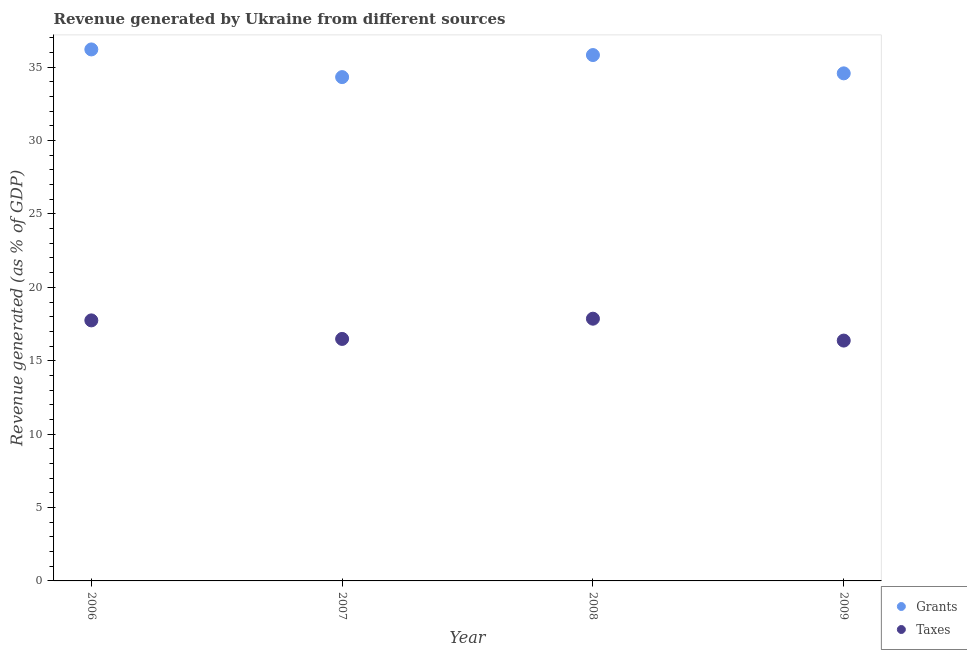What is the revenue generated by taxes in 2009?
Ensure brevity in your answer.  16.37. Across all years, what is the maximum revenue generated by taxes?
Offer a terse response. 17.86. Across all years, what is the minimum revenue generated by grants?
Your answer should be compact. 34.32. In which year was the revenue generated by taxes maximum?
Provide a short and direct response. 2008. What is the total revenue generated by taxes in the graph?
Offer a terse response. 68.47. What is the difference between the revenue generated by taxes in 2008 and that in 2009?
Your response must be concise. 1.49. What is the difference between the revenue generated by grants in 2007 and the revenue generated by taxes in 2008?
Keep it short and to the point. 16.46. What is the average revenue generated by taxes per year?
Keep it short and to the point. 17.12. In the year 2009, what is the difference between the revenue generated by grants and revenue generated by taxes?
Provide a succinct answer. 18.2. In how many years, is the revenue generated by taxes greater than 22 %?
Offer a very short reply. 0. What is the ratio of the revenue generated by grants in 2007 to that in 2008?
Provide a succinct answer. 0.96. Is the revenue generated by grants in 2007 less than that in 2009?
Your response must be concise. Yes. Is the difference between the revenue generated by grants in 2006 and 2007 greater than the difference between the revenue generated by taxes in 2006 and 2007?
Keep it short and to the point. Yes. What is the difference between the highest and the second highest revenue generated by taxes?
Your answer should be very brief. 0.12. What is the difference between the highest and the lowest revenue generated by grants?
Provide a succinct answer. 1.88. Is the revenue generated by taxes strictly greater than the revenue generated by grants over the years?
Provide a short and direct response. No. How many years are there in the graph?
Your response must be concise. 4. What is the difference between two consecutive major ticks on the Y-axis?
Give a very brief answer. 5. Are the values on the major ticks of Y-axis written in scientific E-notation?
Provide a short and direct response. No. Where does the legend appear in the graph?
Make the answer very short. Bottom right. What is the title of the graph?
Give a very brief answer. Revenue generated by Ukraine from different sources. Does "Methane" appear as one of the legend labels in the graph?
Your answer should be very brief. No. What is the label or title of the X-axis?
Offer a very short reply. Year. What is the label or title of the Y-axis?
Offer a very short reply. Revenue generated (as % of GDP). What is the Revenue generated (as % of GDP) in Grants in 2006?
Your answer should be compact. 36.2. What is the Revenue generated (as % of GDP) in Taxes in 2006?
Offer a very short reply. 17.75. What is the Revenue generated (as % of GDP) in Grants in 2007?
Offer a terse response. 34.32. What is the Revenue generated (as % of GDP) of Taxes in 2007?
Keep it short and to the point. 16.48. What is the Revenue generated (as % of GDP) in Grants in 2008?
Ensure brevity in your answer.  35.82. What is the Revenue generated (as % of GDP) of Taxes in 2008?
Your answer should be very brief. 17.86. What is the Revenue generated (as % of GDP) of Grants in 2009?
Offer a very short reply. 34.58. What is the Revenue generated (as % of GDP) of Taxes in 2009?
Provide a short and direct response. 16.37. Across all years, what is the maximum Revenue generated (as % of GDP) of Grants?
Your response must be concise. 36.2. Across all years, what is the maximum Revenue generated (as % of GDP) in Taxes?
Your answer should be compact. 17.86. Across all years, what is the minimum Revenue generated (as % of GDP) in Grants?
Your answer should be compact. 34.32. Across all years, what is the minimum Revenue generated (as % of GDP) of Taxes?
Ensure brevity in your answer.  16.37. What is the total Revenue generated (as % of GDP) in Grants in the graph?
Offer a terse response. 140.92. What is the total Revenue generated (as % of GDP) of Taxes in the graph?
Your answer should be very brief. 68.47. What is the difference between the Revenue generated (as % of GDP) of Grants in 2006 and that in 2007?
Your answer should be very brief. 1.88. What is the difference between the Revenue generated (as % of GDP) in Taxes in 2006 and that in 2007?
Make the answer very short. 1.26. What is the difference between the Revenue generated (as % of GDP) of Grants in 2006 and that in 2008?
Provide a short and direct response. 0.38. What is the difference between the Revenue generated (as % of GDP) in Taxes in 2006 and that in 2008?
Keep it short and to the point. -0.12. What is the difference between the Revenue generated (as % of GDP) of Grants in 2006 and that in 2009?
Offer a terse response. 1.63. What is the difference between the Revenue generated (as % of GDP) in Taxes in 2006 and that in 2009?
Offer a terse response. 1.38. What is the difference between the Revenue generated (as % of GDP) of Grants in 2007 and that in 2008?
Ensure brevity in your answer.  -1.5. What is the difference between the Revenue generated (as % of GDP) in Taxes in 2007 and that in 2008?
Provide a short and direct response. -1.38. What is the difference between the Revenue generated (as % of GDP) of Grants in 2007 and that in 2009?
Keep it short and to the point. -0.26. What is the difference between the Revenue generated (as % of GDP) in Taxes in 2007 and that in 2009?
Keep it short and to the point. 0.11. What is the difference between the Revenue generated (as % of GDP) in Grants in 2008 and that in 2009?
Offer a terse response. 1.25. What is the difference between the Revenue generated (as % of GDP) in Taxes in 2008 and that in 2009?
Your answer should be very brief. 1.49. What is the difference between the Revenue generated (as % of GDP) in Grants in 2006 and the Revenue generated (as % of GDP) in Taxes in 2007?
Make the answer very short. 19.72. What is the difference between the Revenue generated (as % of GDP) of Grants in 2006 and the Revenue generated (as % of GDP) of Taxes in 2008?
Make the answer very short. 18.34. What is the difference between the Revenue generated (as % of GDP) of Grants in 2006 and the Revenue generated (as % of GDP) of Taxes in 2009?
Offer a very short reply. 19.83. What is the difference between the Revenue generated (as % of GDP) in Grants in 2007 and the Revenue generated (as % of GDP) in Taxes in 2008?
Keep it short and to the point. 16.46. What is the difference between the Revenue generated (as % of GDP) of Grants in 2007 and the Revenue generated (as % of GDP) of Taxes in 2009?
Your answer should be very brief. 17.95. What is the difference between the Revenue generated (as % of GDP) in Grants in 2008 and the Revenue generated (as % of GDP) in Taxes in 2009?
Ensure brevity in your answer.  19.45. What is the average Revenue generated (as % of GDP) in Grants per year?
Offer a terse response. 35.23. What is the average Revenue generated (as % of GDP) of Taxes per year?
Provide a succinct answer. 17.12. In the year 2006, what is the difference between the Revenue generated (as % of GDP) in Grants and Revenue generated (as % of GDP) in Taxes?
Provide a succinct answer. 18.46. In the year 2007, what is the difference between the Revenue generated (as % of GDP) in Grants and Revenue generated (as % of GDP) in Taxes?
Provide a short and direct response. 17.84. In the year 2008, what is the difference between the Revenue generated (as % of GDP) in Grants and Revenue generated (as % of GDP) in Taxes?
Provide a short and direct response. 17.96. In the year 2009, what is the difference between the Revenue generated (as % of GDP) in Grants and Revenue generated (as % of GDP) in Taxes?
Provide a succinct answer. 18.2. What is the ratio of the Revenue generated (as % of GDP) in Grants in 2006 to that in 2007?
Provide a succinct answer. 1.05. What is the ratio of the Revenue generated (as % of GDP) of Taxes in 2006 to that in 2007?
Ensure brevity in your answer.  1.08. What is the ratio of the Revenue generated (as % of GDP) in Grants in 2006 to that in 2008?
Your answer should be very brief. 1.01. What is the ratio of the Revenue generated (as % of GDP) of Grants in 2006 to that in 2009?
Give a very brief answer. 1.05. What is the ratio of the Revenue generated (as % of GDP) in Taxes in 2006 to that in 2009?
Make the answer very short. 1.08. What is the ratio of the Revenue generated (as % of GDP) of Grants in 2007 to that in 2008?
Your answer should be compact. 0.96. What is the ratio of the Revenue generated (as % of GDP) in Taxes in 2007 to that in 2008?
Give a very brief answer. 0.92. What is the ratio of the Revenue generated (as % of GDP) in Grants in 2007 to that in 2009?
Offer a terse response. 0.99. What is the ratio of the Revenue generated (as % of GDP) of Taxes in 2007 to that in 2009?
Provide a short and direct response. 1.01. What is the ratio of the Revenue generated (as % of GDP) in Grants in 2008 to that in 2009?
Your answer should be very brief. 1.04. What is the ratio of the Revenue generated (as % of GDP) of Taxes in 2008 to that in 2009?
Offer a terse response. 1.09. What is the difference between the highest and the second highest Revenue generated (as % of GDP) of Grants?
Provide a succinct answer. 0.38. What is the difference between the highest and the second highest Revenue generated (as % of GDP) of Taxes?
Your answer should be compact. 0.12. What is the difference between the highest and the lowest Revenue generated (as % of GDP) of Grants?
Offer a very short reply. 1.88. What is the difference between the highest and the lowest Revenue generated (as % of GDP) in Taxes?
Offer a terse response. 1.49. 